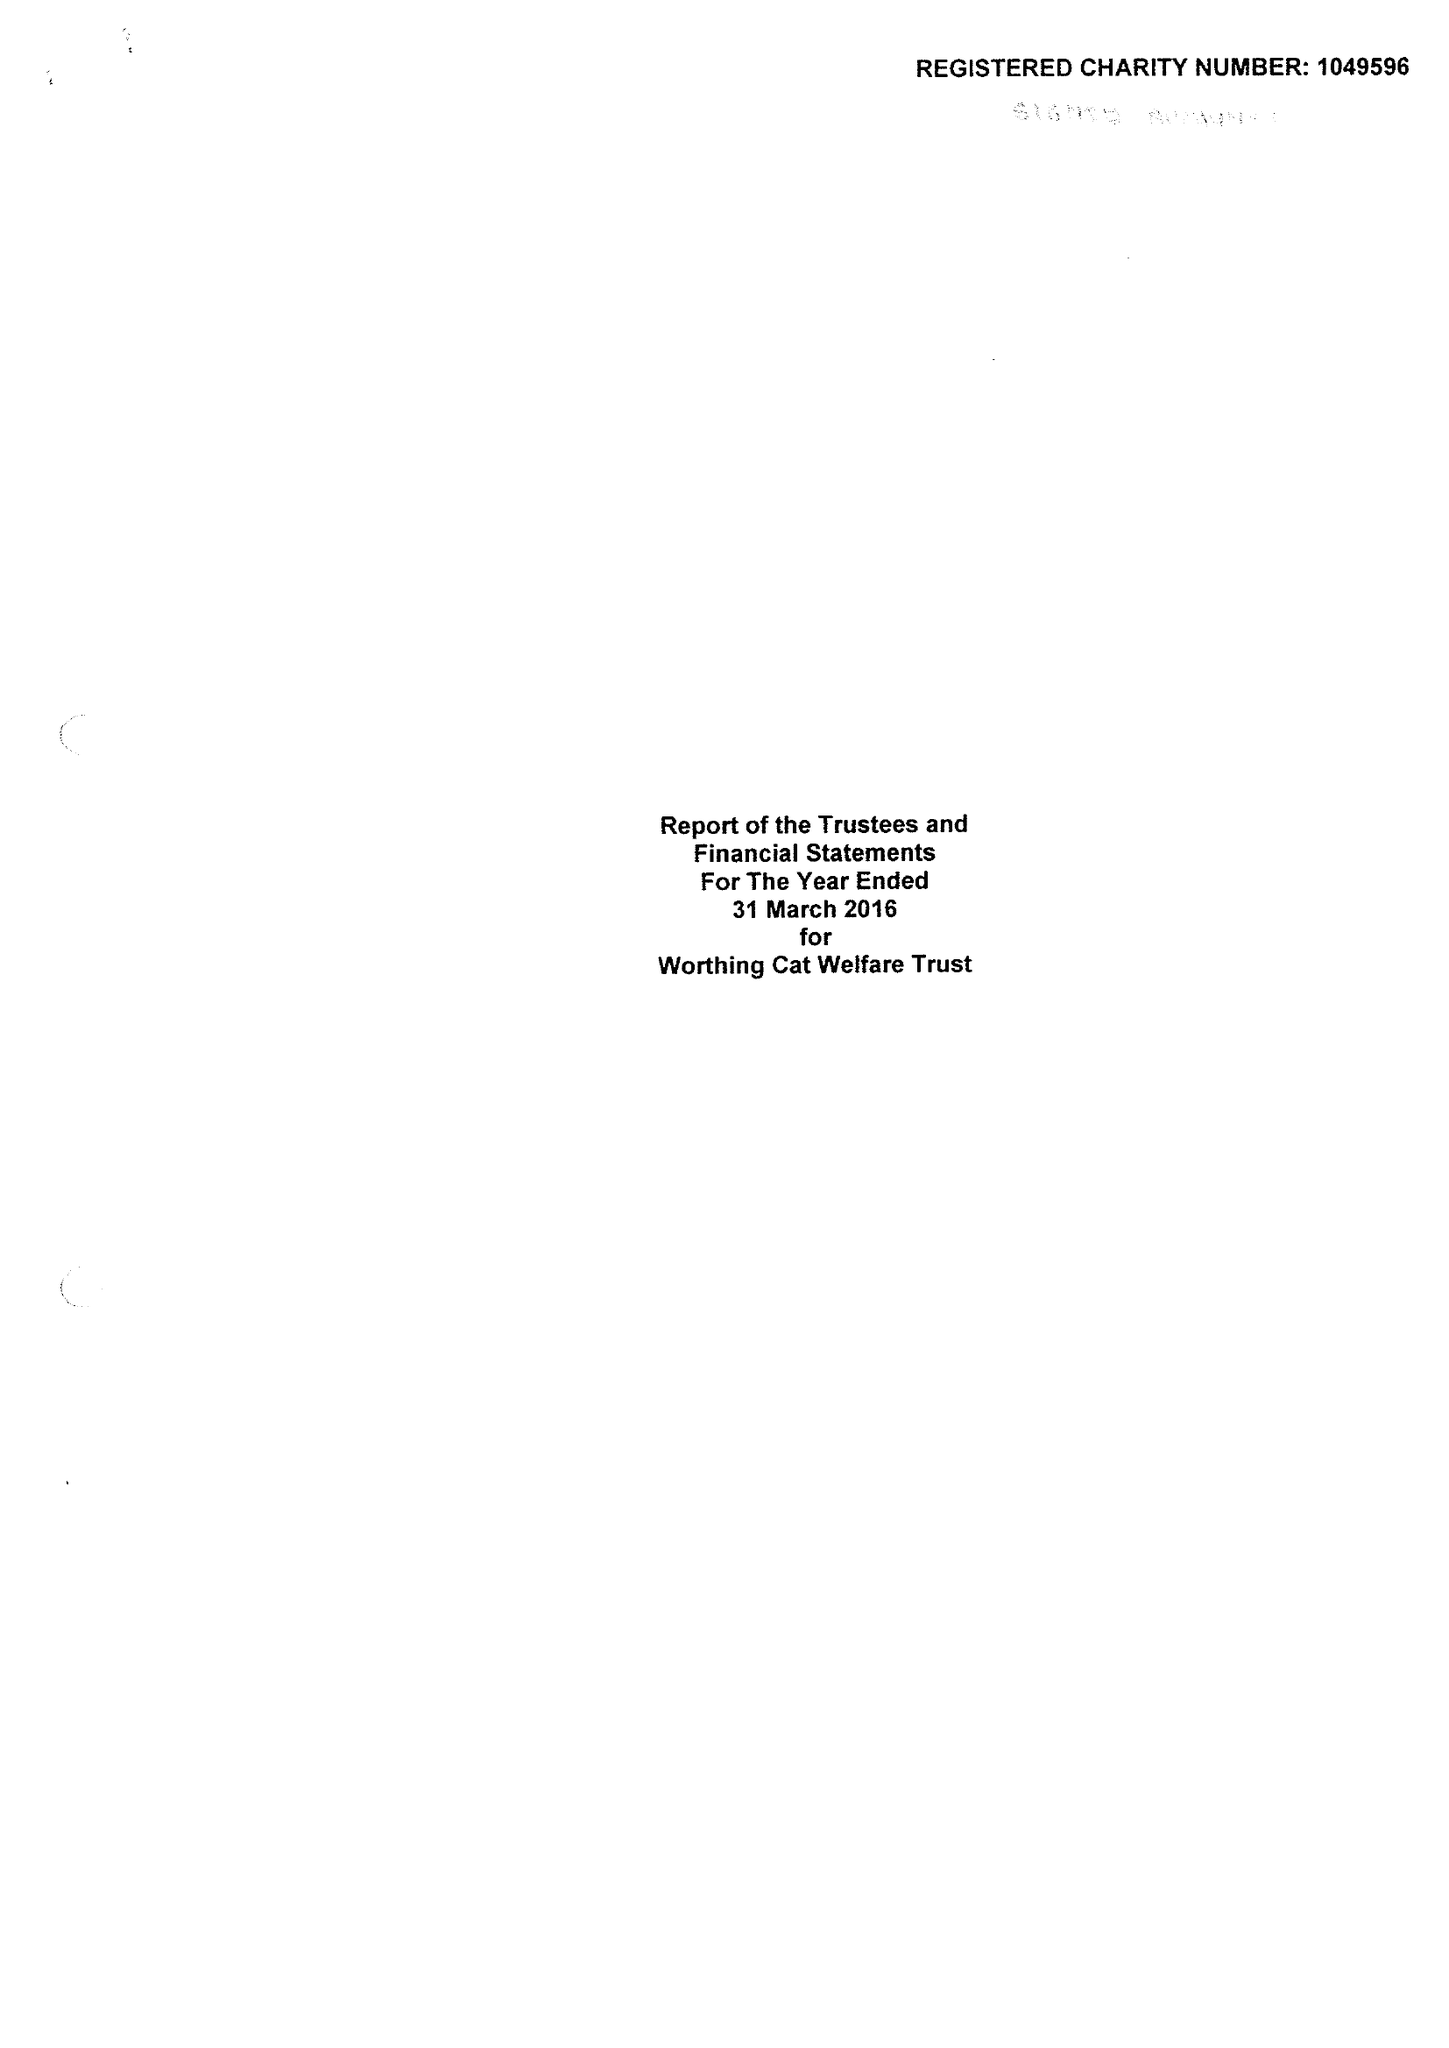What is the value for the report_date?
Answer the question using a single word or phrase. 2016-03-31 